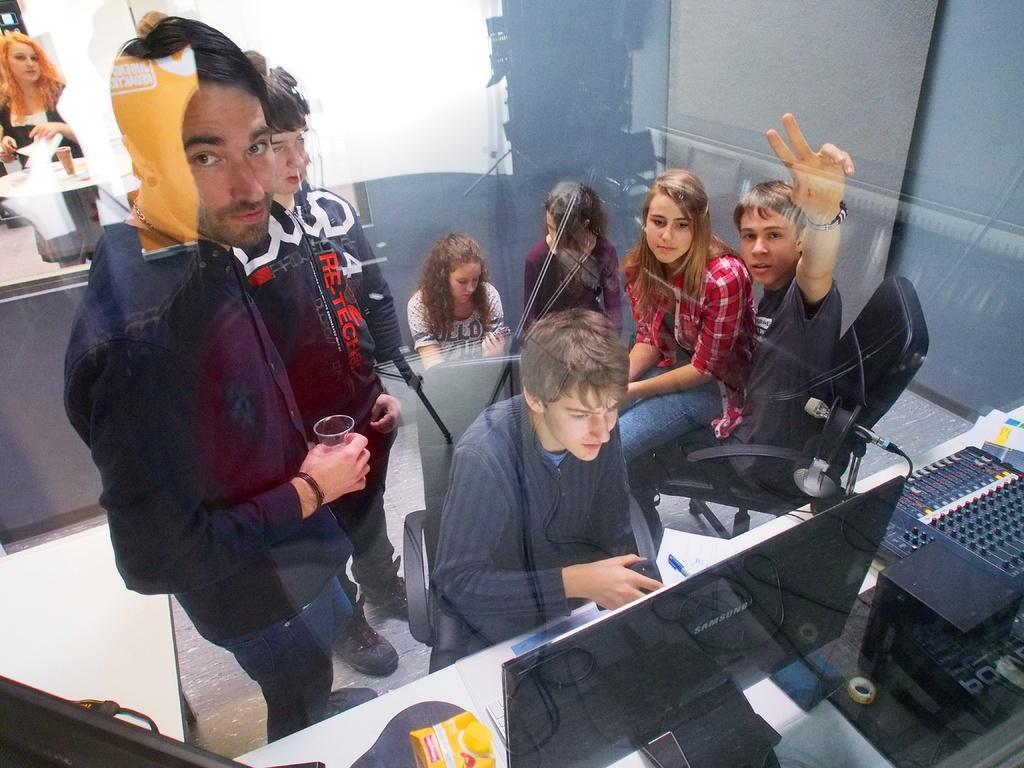Can you describe this image briefly? In the center of the image there is a person sitting on a chair. At the bottom of the image there are many objects on the table like monitor,mic. At the center of the image there is a person holding a glass in his hand. There are many people in the image. At the background of the image there is a wall. 